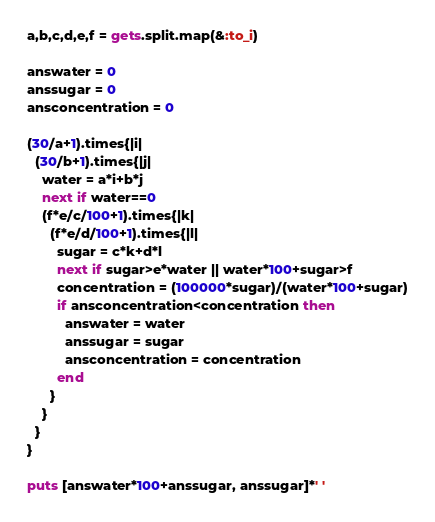Convert code to text. <code><loc_0><loc_0><loc_500><loc_500><_Ruby_>a,b,c,d,e,f = gets.split.map(&:to_i)

answater = 0
anssugar = 0
ansconcentration = 0

(30/a+1).times{|i|
  (30/b+1).times{|j|
    water = a*i+b*j
    next if water==0
    (f*e/c/100+1).times{|k|
      (f*e/d/100+1).times{|l|
        sugar = c*k+d*l
        next if sugar>e*water || water*100+sugar>f
        concentration = (100000*sugar)/(water*100+sugar)
        if ansconcentration<concentration then
          answater = water
          anssugar = sugar
          ansconcentration = concentration
        end
      }
    }
  }
}

puts [answater*100+anssugar, anssugar]*' '</code> 